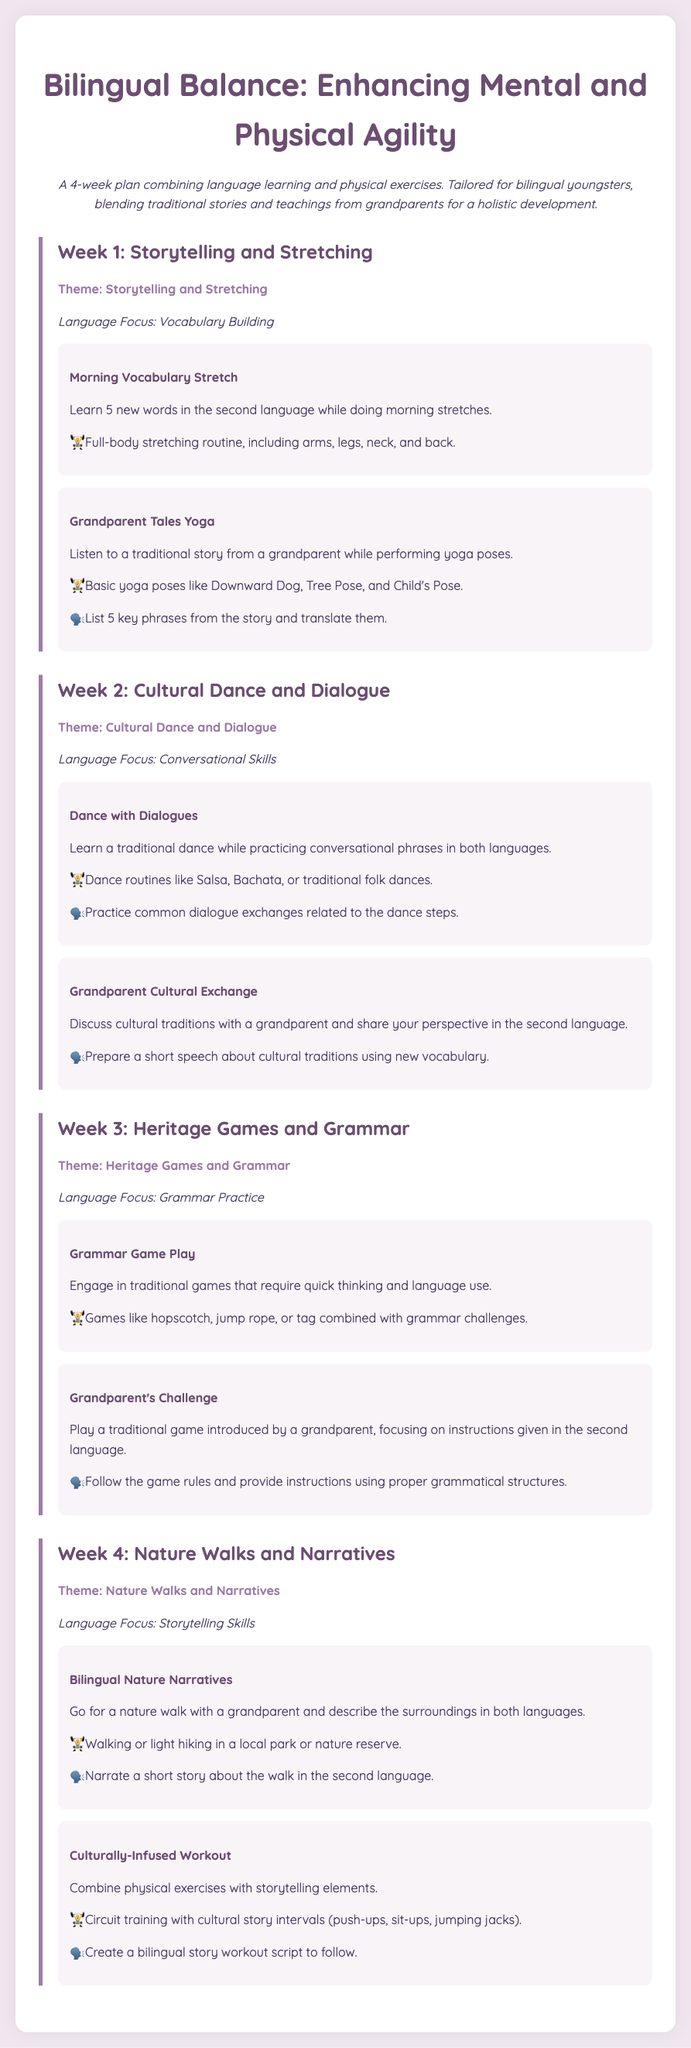What is the theme of Week 1? The theme of Week 1 is mentioned explicitly in the document as "Storytelling and Stretching."
Answer: Storytelling and Stretching How many key phrases must be translated in Week 1's activity? The document specifies that 5 key phrases need to be listed and translated in the yoga activity.
Answer: 5 key phrases What type of dance is learned in Week 2? The document lists traditional dance styles that will be learned and mentions Salsa and Bachata as examples.
Answer: Salsa, Bachata What language focus is emphasized in Week 3? The document clearly states that the language focus for Week 3 is Grammar Practice.
Answer: Grammar Practice What physical activity is included in the fourth week's nature walk? The nature activity involves walking or light hiking, as noted in the description.
Answer: Walking or light hiking What kind of game is played in Week 3's activity with a grandparent? The document enumerates a specific type of game played that is described in the activity as a traditional game.
Answer: Traditional game What is the purpose of combining storytelling with exercises in Week 4? The document states that it aims to enhance physical exercises by incorporating elements of storytelling, creating a culturally infused experience.
Answer: Culturally-infused experience How many weeks does this workout plan last? The document describes the workout plan structure and indicates that it spans a total of four weeks.
Answer: Four weeks What type of physical exercises are included in the "Culturally-Infused Workout"? The document mentions specific exercises that are part of this workout, including push-ups, sit-ups, and jumping jacks.
Answer: Push-ups, sit-ups, jumping jacks 